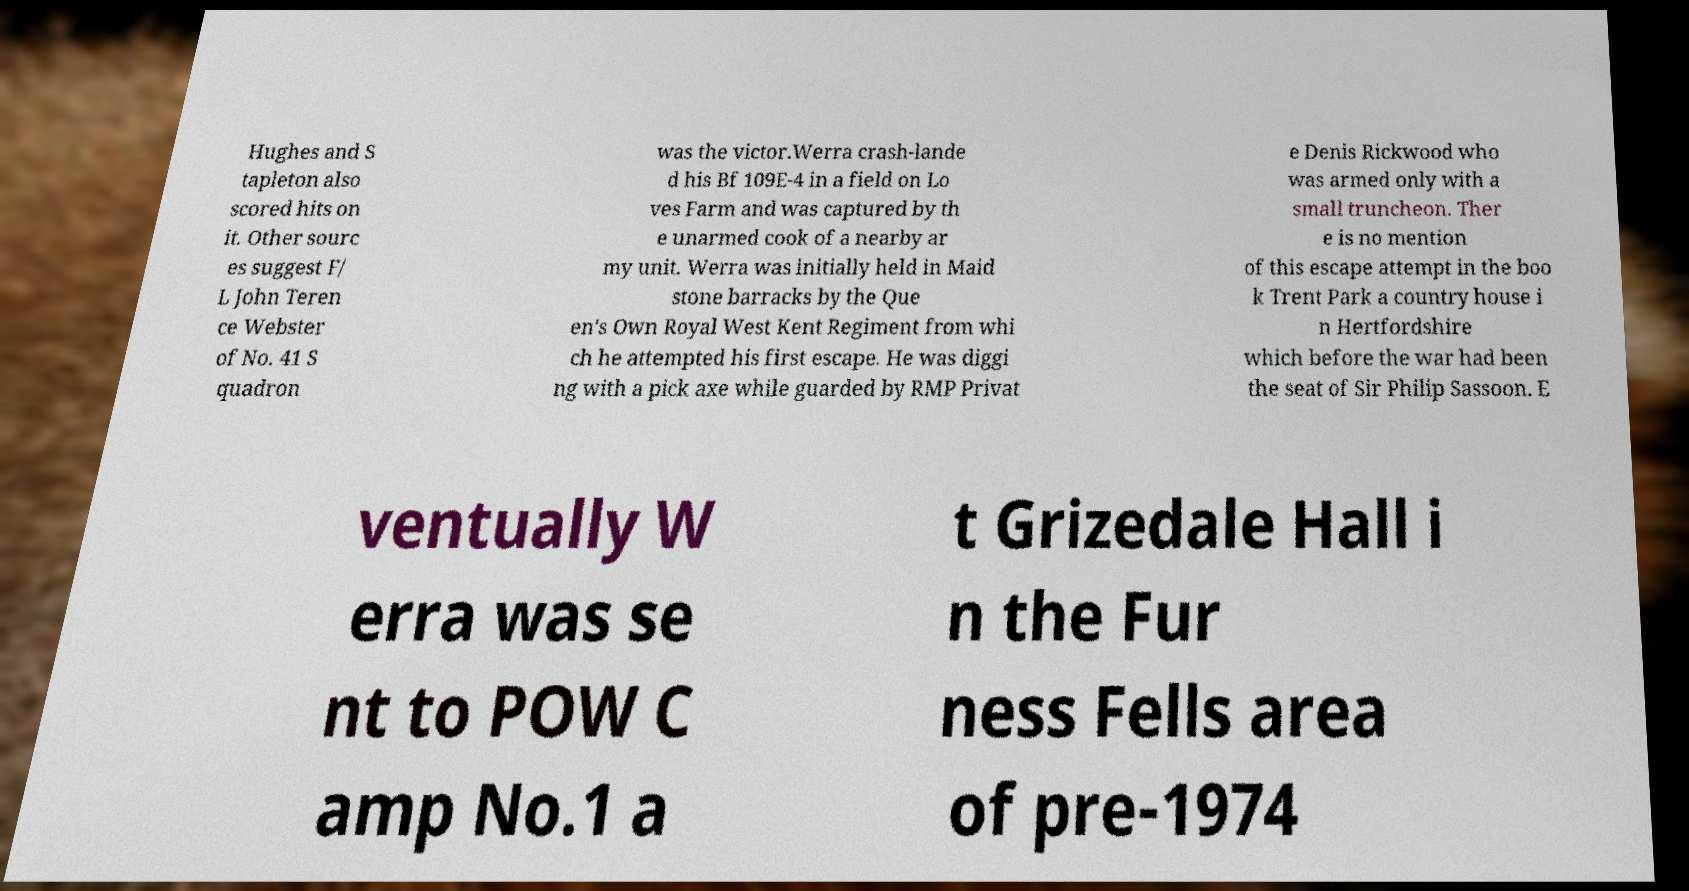Could you assist in decoding the text presented in this image and type it out clearly? Hughes and S tapleton also scored hits on it. Other sourc es suggest F/ L John Teren ce Webster of No. 41 S quadron was the victor.Werra crash-lande d his Bf 109E-4 in a field on Lo ves Farm and was captured by th e unarmed cook of a nearby ar my unit. Werra was initially held in Maid stone barracks by the Que en's Own Royal West Kent Regiment from whi ch he attempted his first escape. He was diggi ng with a pick axe while guarded by RMP Privat e Denis Rickwood who was armed only with a small truncheon. Ther e is no mention of this escape attempt in the boo k Trent Park a country house i n Hertfordshire which before the war had been the seat of Sir Philip Sassoon. E ventually W erra was se nt to POW C amp No.1 a t Grizedale Hall i n the Fur ness Fells area of pre-1974 